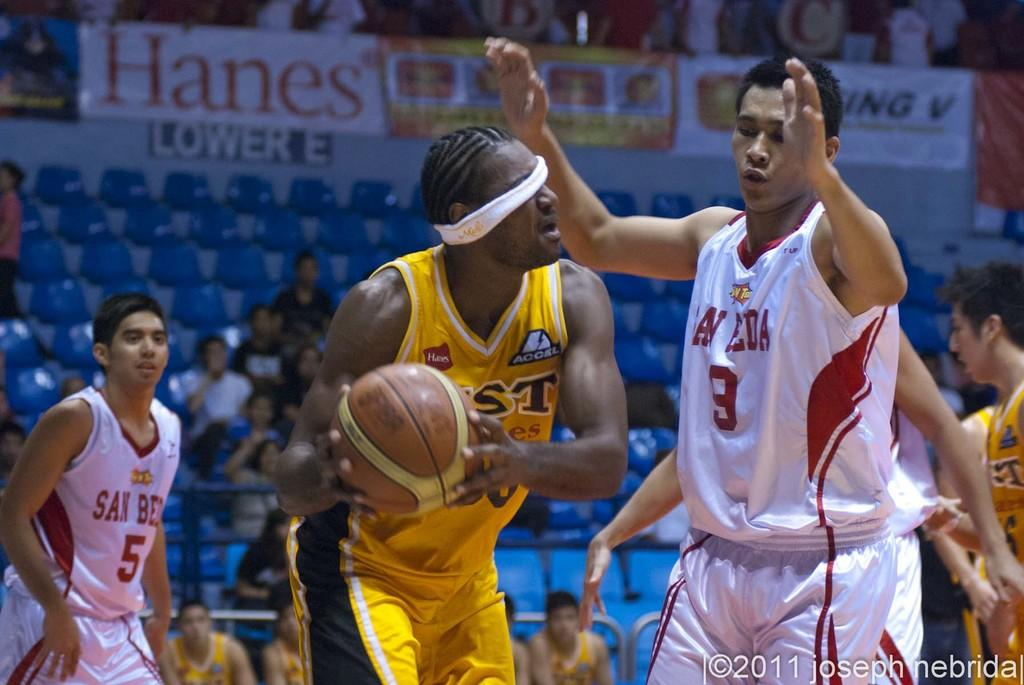<image>
Provide a brief description of the given image. A black blindfolded man in a yellow jersey with a Hanes sponsor holds basketball. 